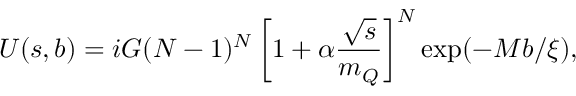Convert formula to latex. <formula><loc_0><loc_0><loc_500><loc_500>U ( s , b ) = i G ( N - 1 ) ^ { N } \left [ 1 + \alpha \frac { \sqrt { s } } { m _ { Q } } \right ] ^ { N } \exp ( - M b / \xi ) ,</formula> 